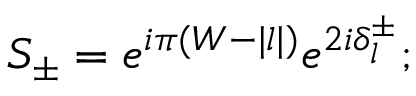Convert formula to latex. <formula><loc_0><loc_0><loc_500><loc_500>S _ { \pm } = e ^ { i \pi ( W - | l | ) } e ^ { 2 i \delta _ { l } ^ { \pm } } ;</formula> 